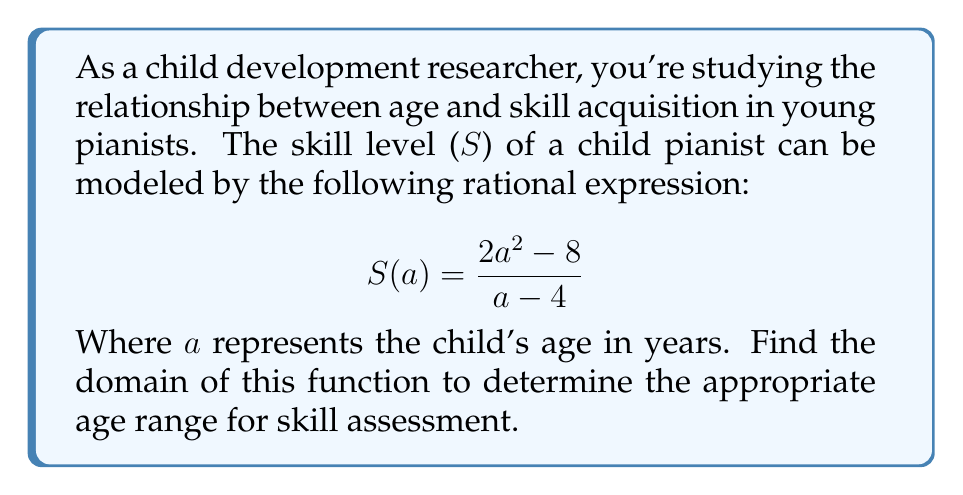Can you answer this question? To find the domain of the rational expression, we need to determine the values of $a$ for which the expression is defined. The key steps are:

1) A rational expression is undefined when its denominator equals zero. So, we need to solve:
   $$a - 4 = 0$$
   $$a = 4$$

2) This means the function is undefined when $a = 4$.

3) The domain of the function includes all real numbers except for the value that makes the denominator zero.

4) In the context of child development, age cannot be negative. Therefore, we also need to consider $a > 0$ as a constraint.

5) Combining these conditions, we can express the domain as:
   $$\{a \in \mathbb{R} : a > 0 \text{ and } a \neq 4\}$$

6) In interval notation, this can be written as:
   $$(0, 4) \cup (4, \infty)$$

This domain represents the age range (in years) for which the skill assessment model is valid, excluding age 4 where the model breaks down.
Answer: $(0, 4) \cup (4, \infty)$ 